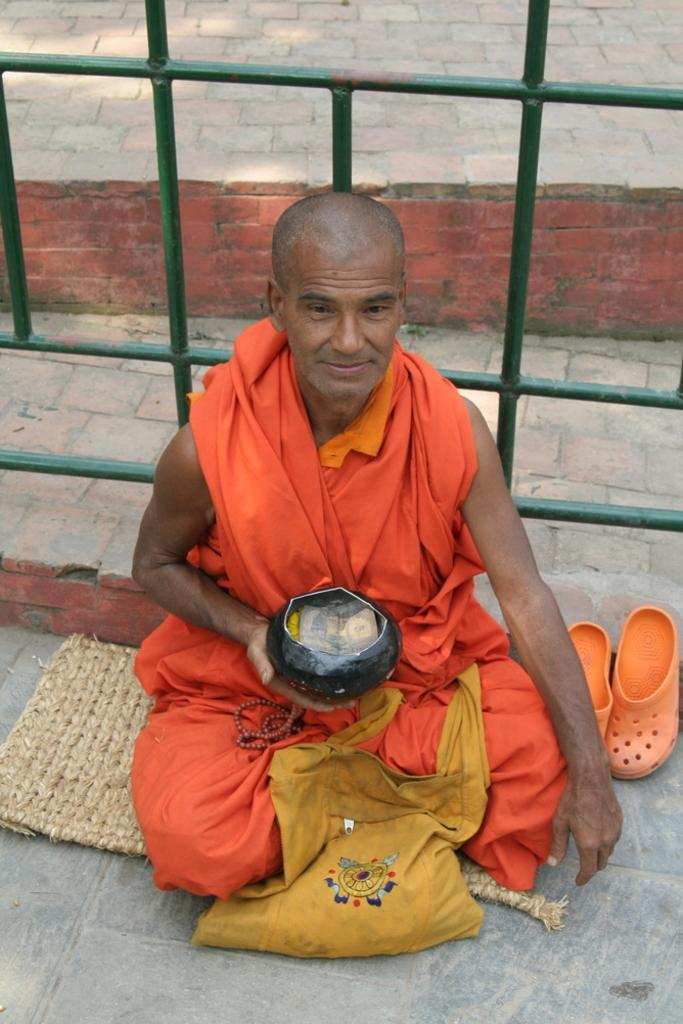Who is present in the image? There is a man in the image. What is the man wearing? The man is wearing an orange dress. What is the man holding in the image? The man is holding a money box. What type of footwear can be seen in the image? There are shoes visible in the image. What object is present in the image that might be used for carrying items? There is a bag in the image. What type of barrier is visible in the image? There is metal fencing in the image. What surface is the man sitting on in the image? The man is sitting on a mat. What type of beam is supporting the man in the image? There is no beam present in the image; the man is sitting on a mat. How many steps does the man take in the image? There is no indication of the man taking any steps in the image. 